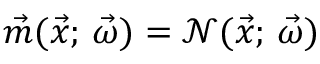<formula> <loc_0><loc_0><loc_500><loc_500>\vec { m } ( \vec { x } ; \, \vec { \omega } ) = \mathcal { N } ( \vec { x } ; \, \vec { \omega } )</formula> 